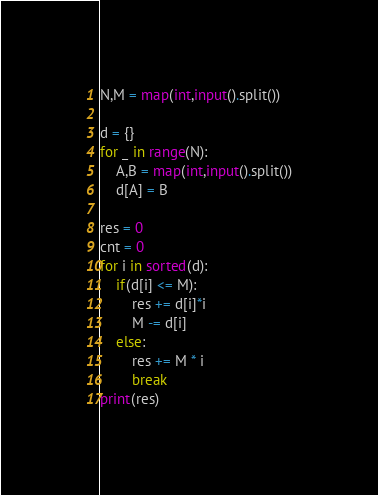Convert code to text. <code><loc_0><loc_0><loc_500><loc_500><_Python_>N,M = map(int,input().split())

d = {}
for _ in range(N):
    A,B = map(int,input().split())
    d[A] = B

res = 0
cnt = 0
for i in sorted(d):
    if(d[i] <= M):
        res += d[i]*i
        M -= d[i]
    else:
        res += M * i
        break
print(res)</code> 